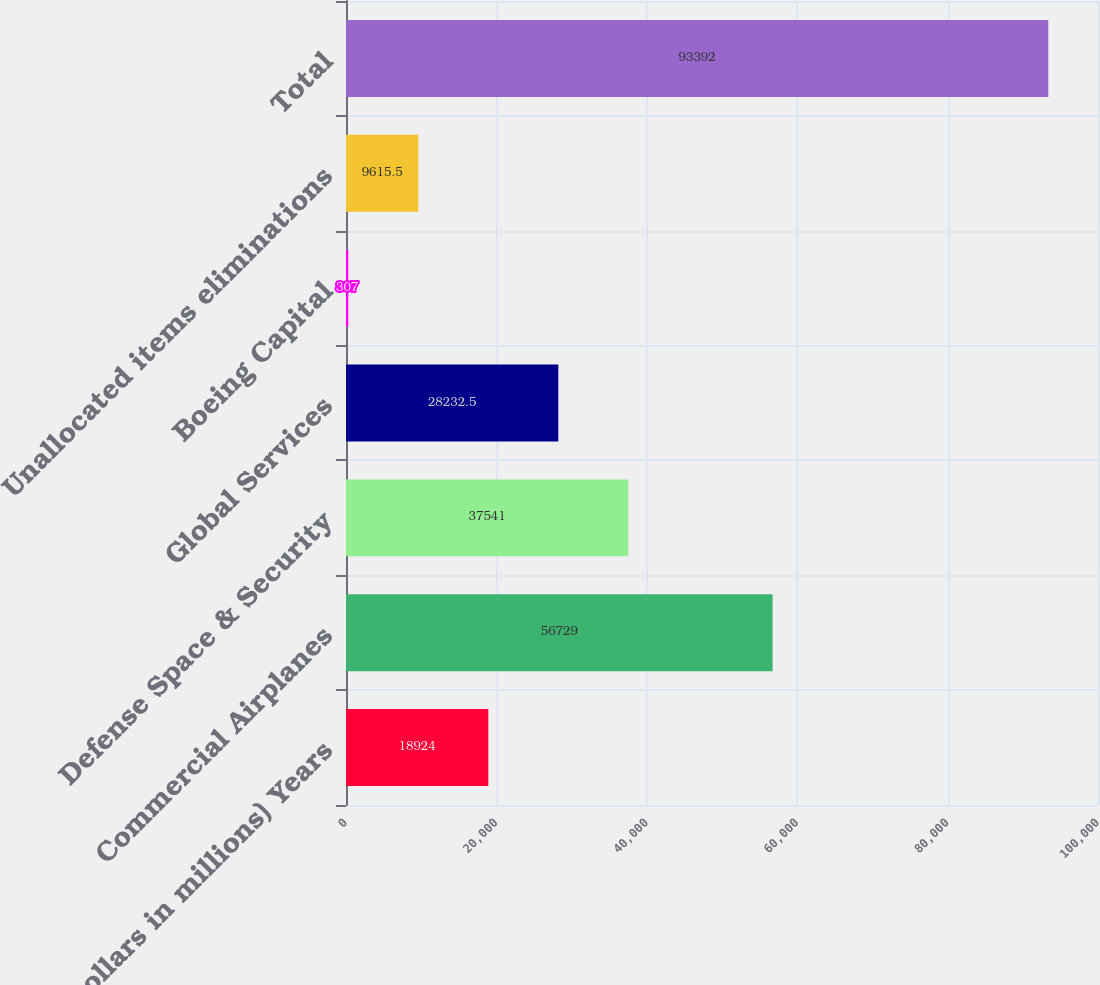Convert chart to OTSL. <chart><loc_0><loc_0><loc_500><loc_500><bar_chart><fcel>(Dollars in millions) Years<fcel>Commercial Airplanes<fcel>Defense Space & Security<fcel>Global Services<fcel>Boeing Capital<fcel>Unallocated items eliminations<fcel>Total<nl><fcel>18924<fcel>56729<fcel>37541<fcel>28232.5<fcel>307<fcel>9615.5<fcel>93392<nl></chart> 